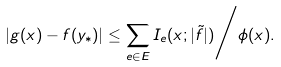Convert formula to latex. <formula><loc_0><loc_0><loc_500><loc_500>| g ( x ) - f ( y _ { * } ) | \leq \sum _ { e \in E } I _ { e } ( x ; | \tilde { f } | ) \Big / \phi ( x ) .</formula> 